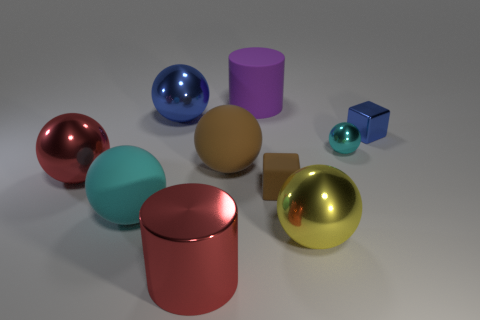Subtract all cyan spheres. How many spheres are left? 4 Subtract all cylinders. How many objects are left? 8 Subtract all blue spheres. How many spheres are left? 5 Subtract 1 cylinders. How many cylinders are left? 1 Subtract all brown spheres. Subtract all purple cylinders. How many spheres are left? 5 Subtract all green cylinders. How many red spheres are left? 1 Subtract all spheres. Subtract all purple objects. How many objects are left? 3 Add 6 large yellow things. How many large yellow things are left? 7 Add 6 large blue objects. How many large blue objects exist? 7 Subtract 0 red cubes. How many objects are left? 10 